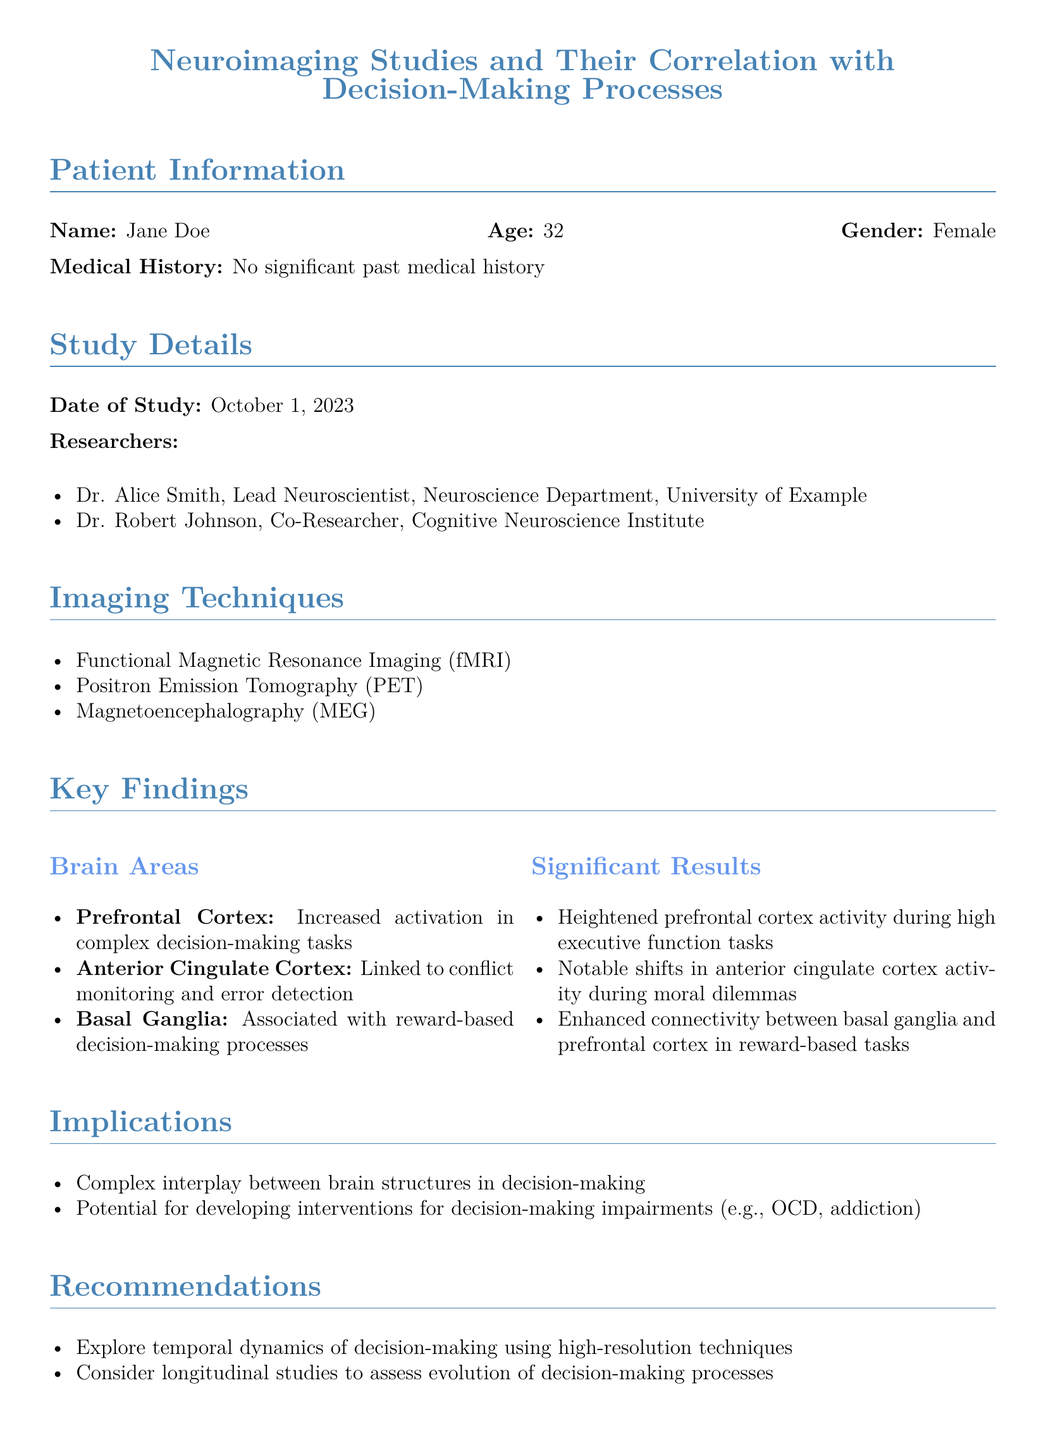What is the name of the patient? The patient's name is listed at the beginning of the document under Patient Information.
Answer: Jane Doe What imaging technique was used for the study? The imaging techniques are listed in the Imaging Techniques section of the document.
Answer: Functional Magnetic Resonance Imaging (fMRI) What is the age of the patient? The patient's age is provided in the Patient Information section.
Answer: 32 Who is the lead neuroscientist in this study? The lead neuroscientist is mentioned in the Researchers section.
Answer: Dr. Alice Smith What brain area is linked to conflict monitoring? The brain areas and their functions are listed in the Key Findings section.
Answer: Anterior Cingulate Cortex What significant result is associated with the prefrontal cortex? The significant results regarding the prefrontal cortex are detailed in the Significant Results section.
Answer: Heightened prefrontal cortex activity during high executive function tasks What is one implication of the study findings? The implications are specified in the Implications section of the document.
Answer: Complex interplay between brain structures in decision-making What do the researchers recommend for future studies? The recommendations for future studies are found in the Recommendations section.
Answer: Explore temporal dynamics of decision-making using high-resolution techniques 